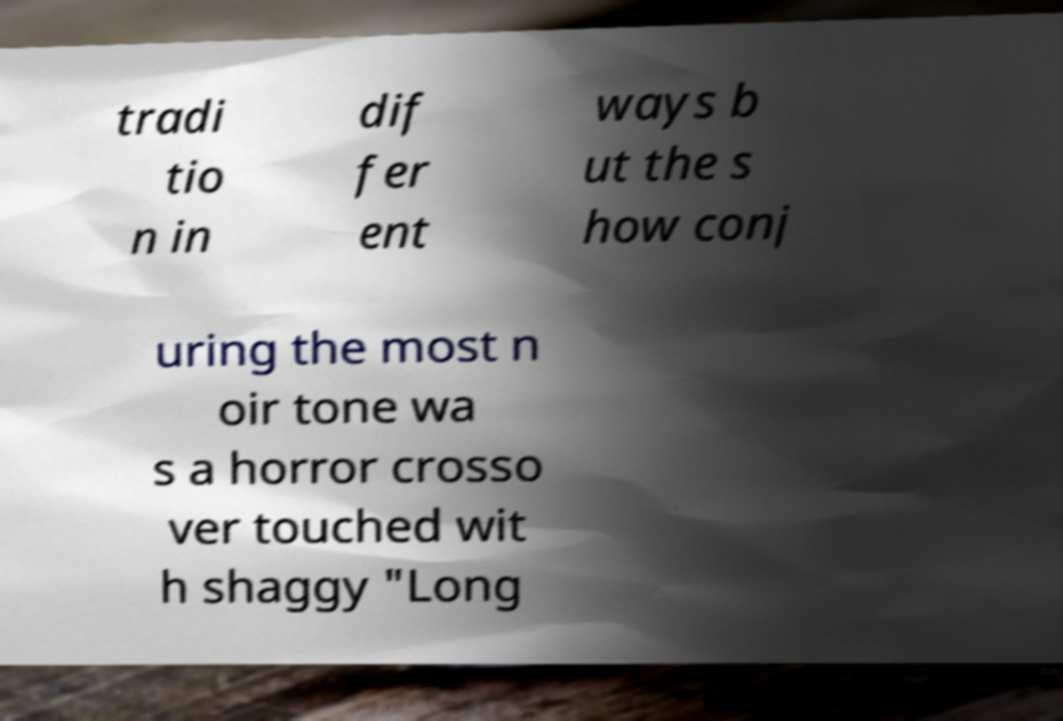Could you extract and type out the text from this image? tradi tio n in dif fer ent ways b ut the s how conj uring the most n oir tone wa s a horror crosso ver touched wit h shaggy "Long 